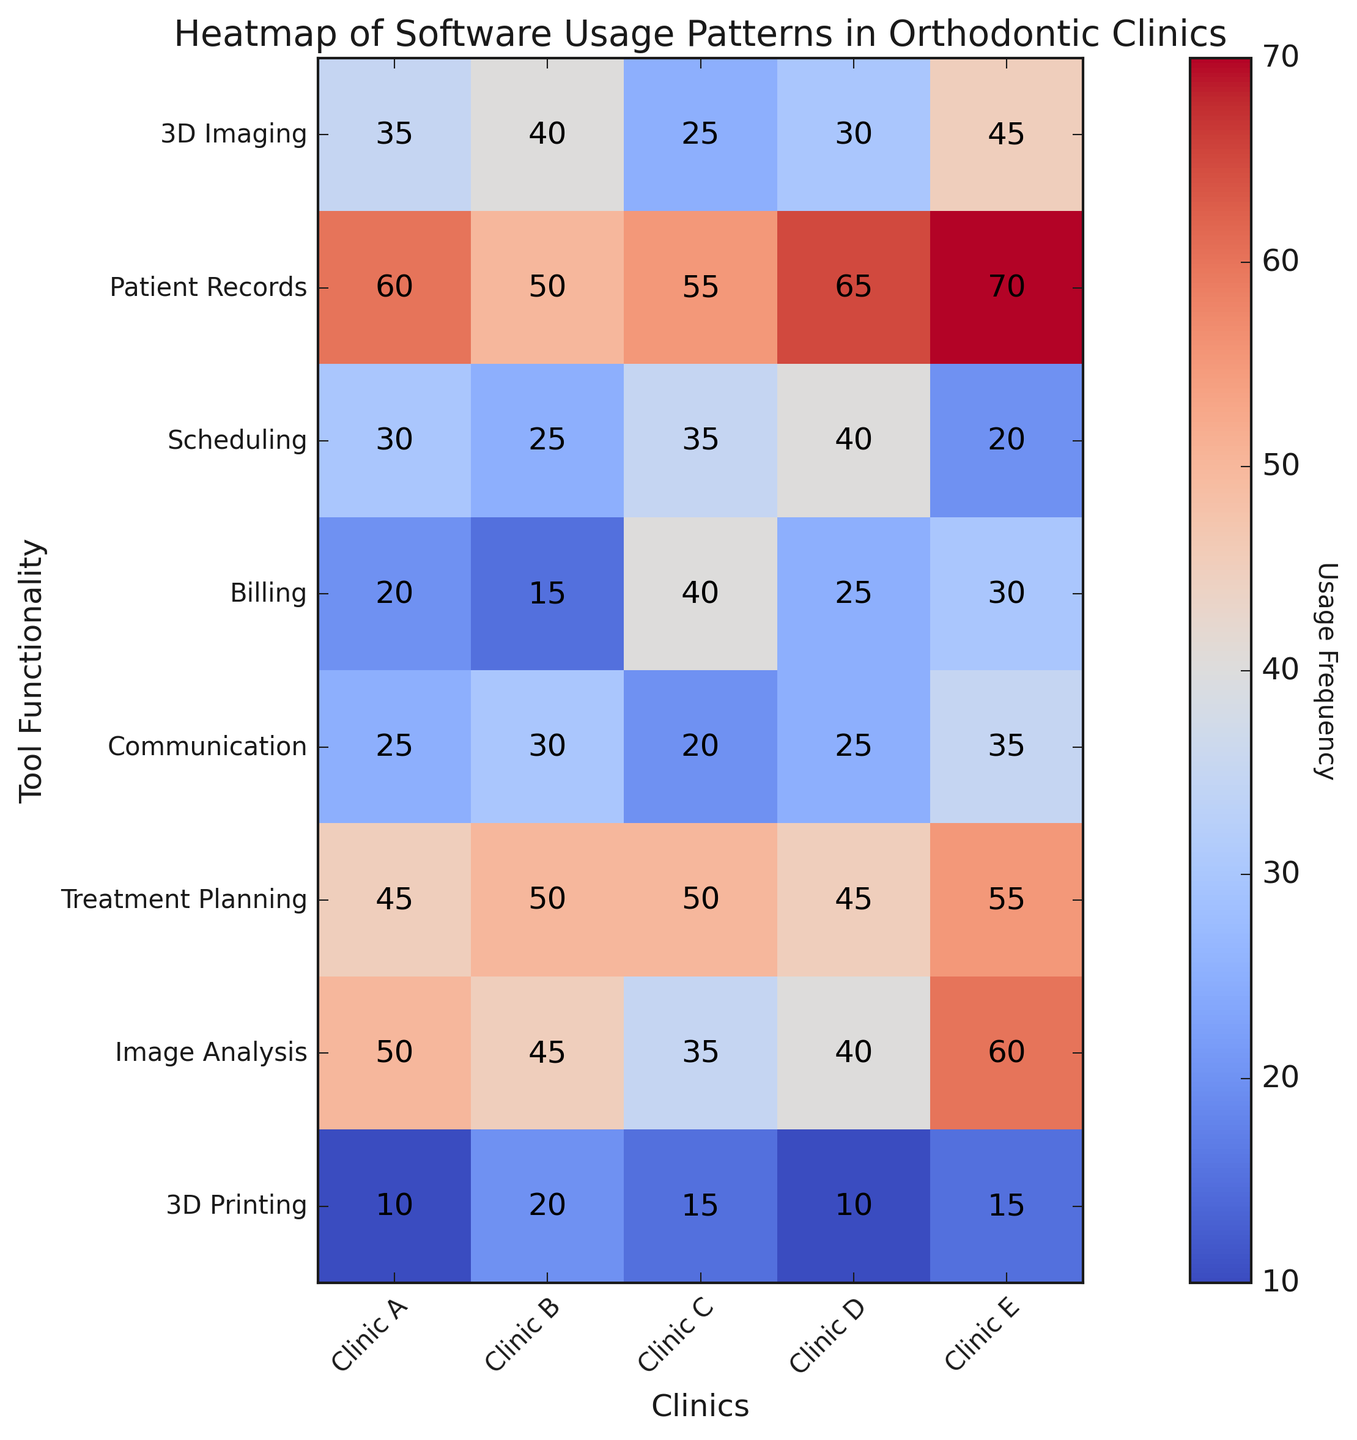Which clinic uses 3D Printing the least? The heatmap shows numerical values inside each cell. By observing the row for 3D Printing, Clinic A and Clinic D both have the lowest value which is 10.
Answer: Clinic A and Clinic D Which tool functionality has the highest usage in Clinic E? By looking at the column for Clinic E, the highest value is in the Treatment Planning row with a value of 55.
Answer: Treatment Planning What's the difference in usage of Patient Records between Clinic C and Clinic D? Clinic C has a usage of 55 and Clinic D has 65. The difference is 65 - 55 = 10.
Answer: 10 Which functionality has a higher average usage, Communication or Billing? Calculate the average for Communication (25+30+20+25+35 = 135, 135/5 = 27) and Billing (20+15+40+25+30 = 130, 130/5 = 26). Communication has a higher average usage of 27.
Answer: Communication What is the total usage of 3D Imaging across all clinics? Sum the values of 3D Imaging across all clinics: 35+40+25+30+45 = 175.
Answer: 175 How does the usage of Scheduling compare across the clinics? By observing the Scheduling row, you can see the values: 30, 25, 35, 40, 20. So, Clinic D has the highest usage and Clinic E has the lowest.
Answer: Clinic D > Clinic C > Clinic A > Clinic B > Clinic E What is the median usage value of Image Analysis across all clinics? To find the median, order the values of Image Analysis: 35, 40, 45, 50, 60. The middle value is 45.
Answer: 45 Which clinic has the least usage overall for all tools? Sum the columns for each clinic: 
Clinic A: 35+60+30+20+25+45+50+10 = 275
Clinic B: 40+50+25+15+30+50+45+20 = 275
Clinic C: 25+55+35+40+20+50+35+15 = 275
Clinic D: 30+65+40+25+25+45+40+10 = 280
Clinic E: 45+70+20+30+35+55+60+15 = 330
Clinics A, B, and C have the least overall usage with a sum of 275 each.
Answer: Clinics A, B, and C 